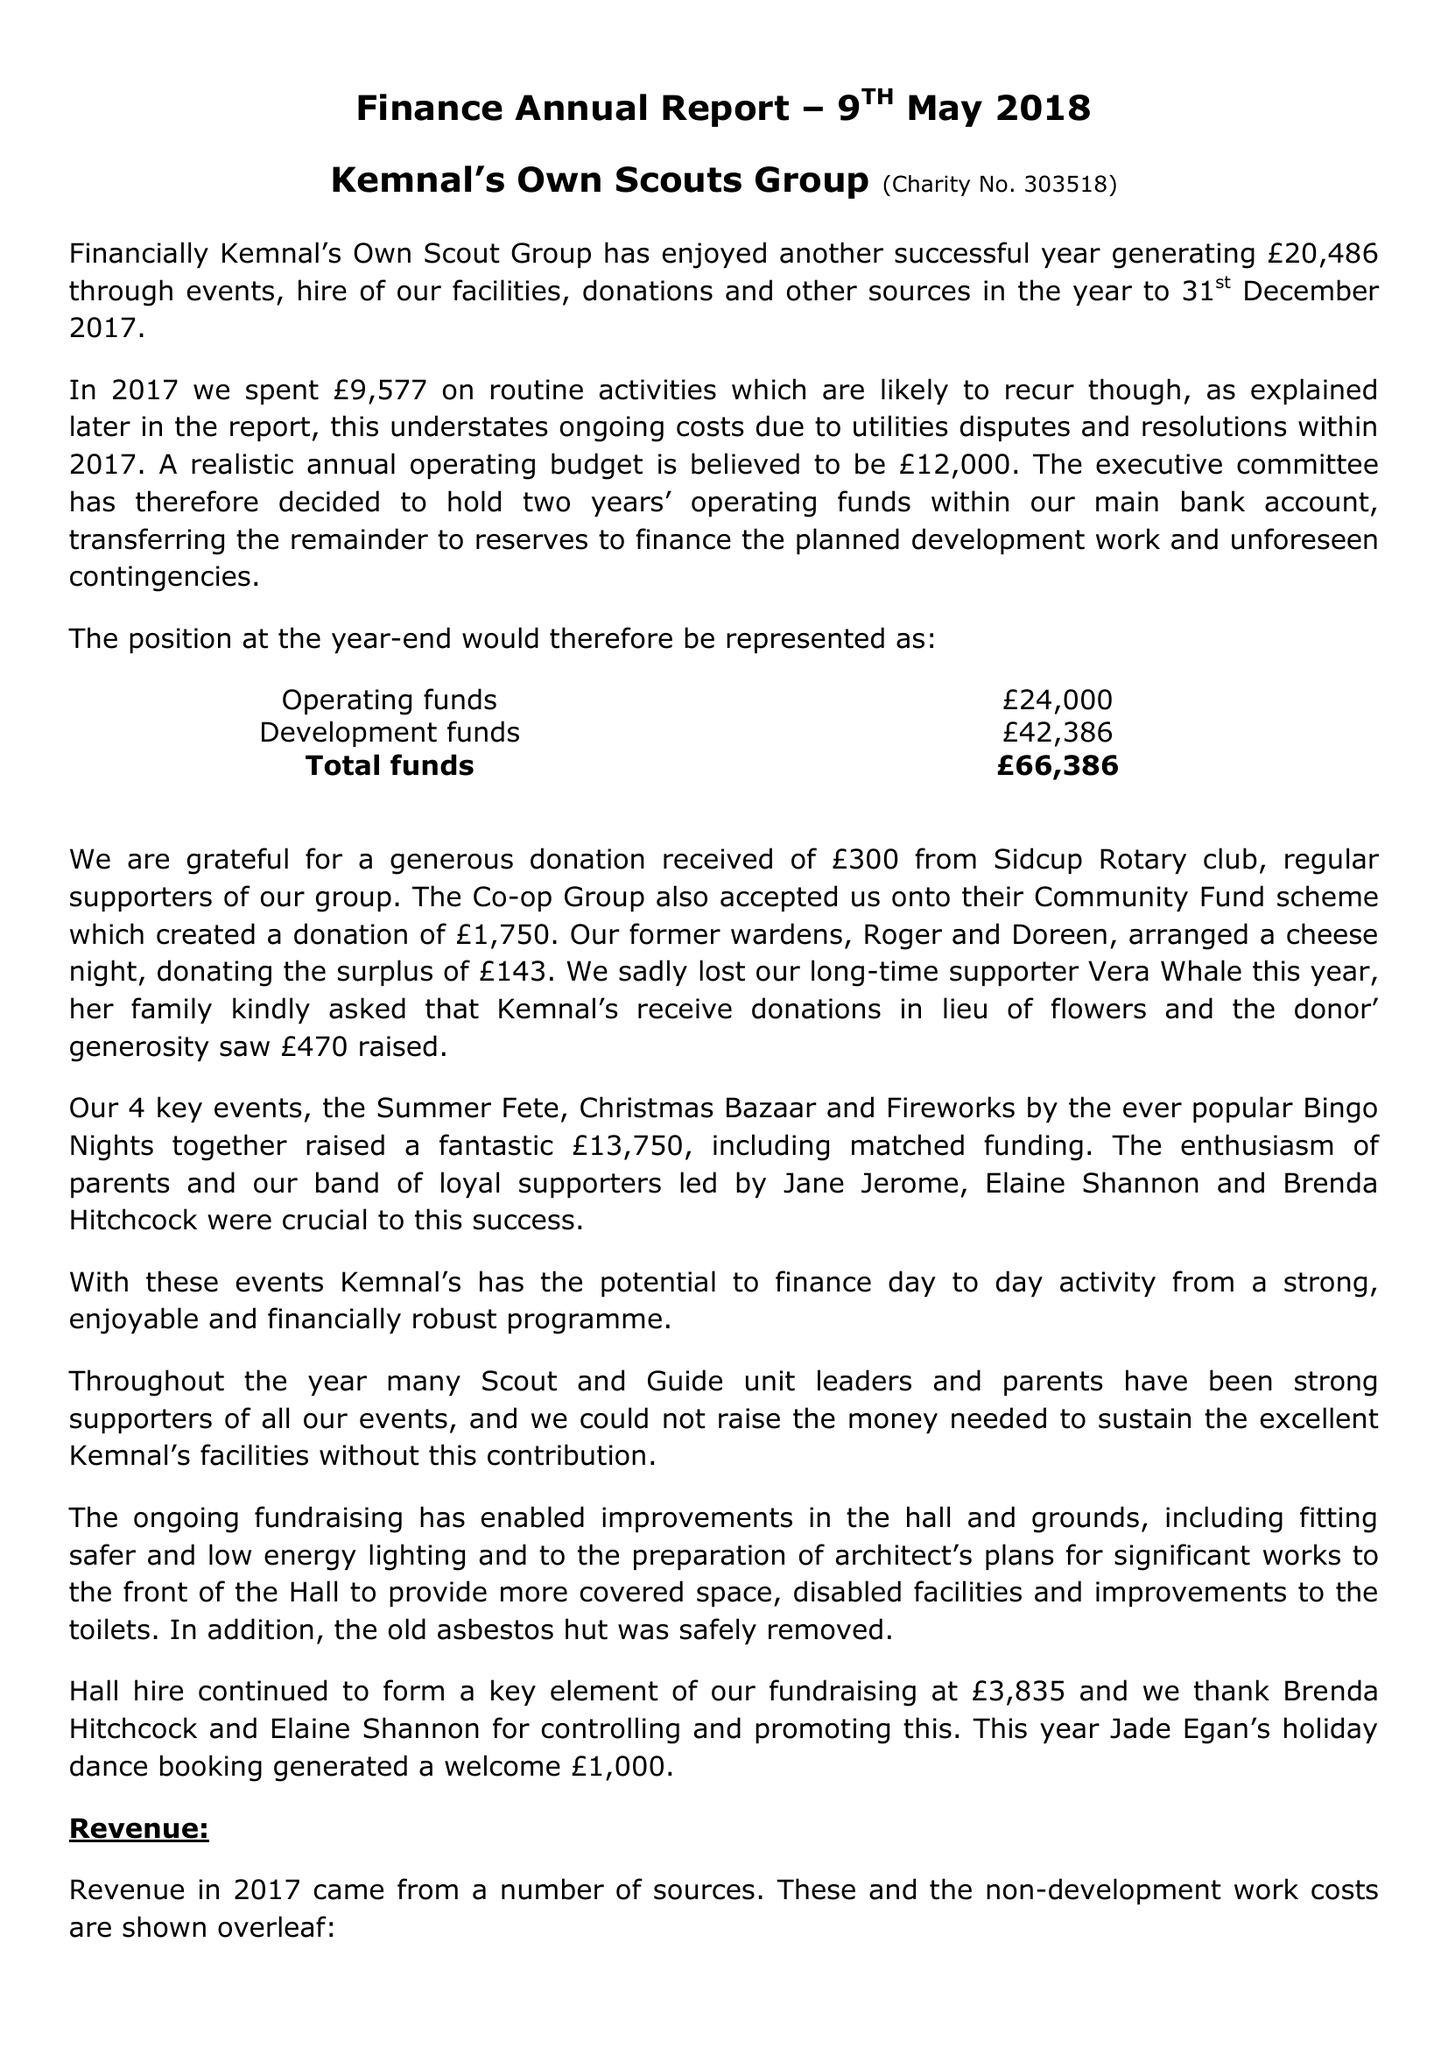What is the value for the report_date?
Answer the question using a single word or phrase. 2017-12-31 